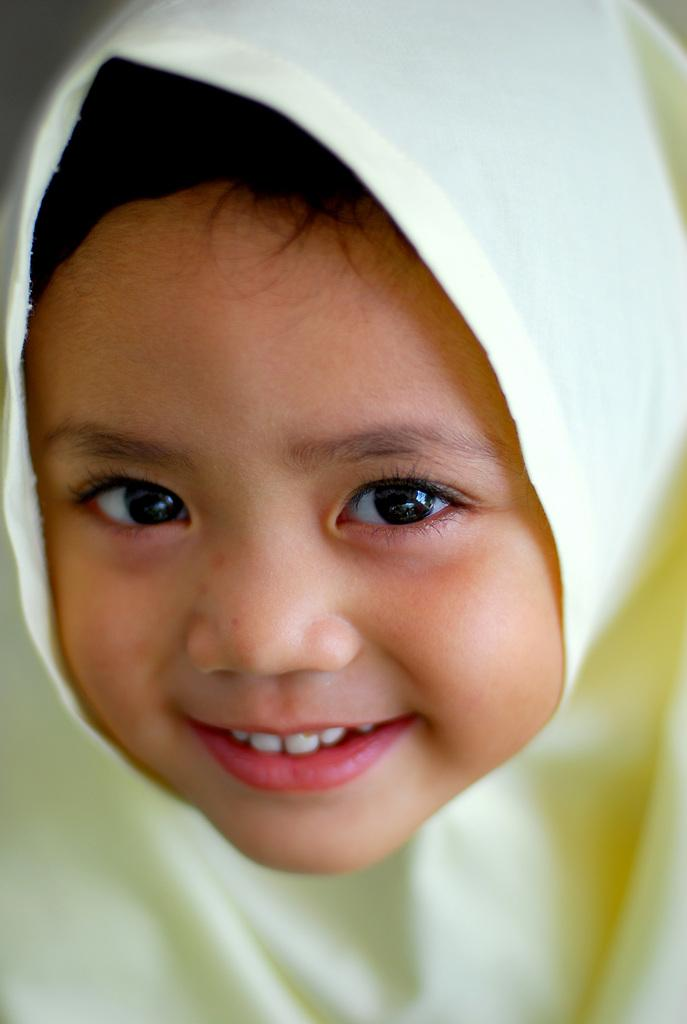What is the main subject of the image? The main subject of the image is a kid. What is the kid doing in the image? The kid is smiling in the image. What type of brick can be seen floating down the river in the image? There is no brick or river present in the image; it only features a kid who is smiling. 